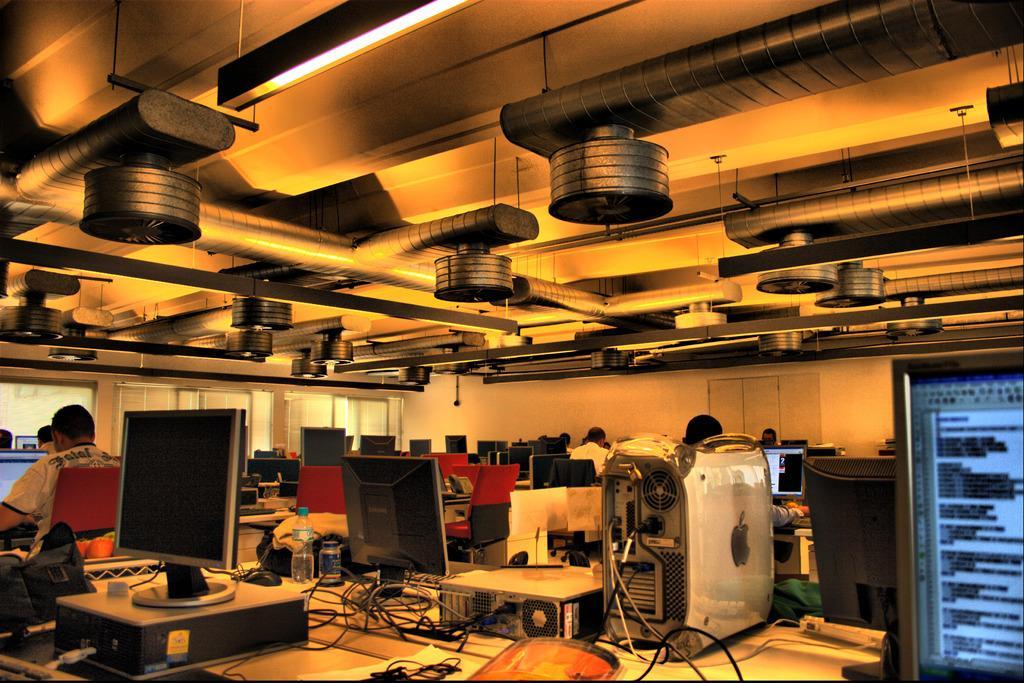Could you give a brief overview of what you see in this image? In this picture I can see a number of personal computers on the table. I can see a few people sitting on the chairs. I can see ventilation pipes. I can see light arrangement on the roof. 